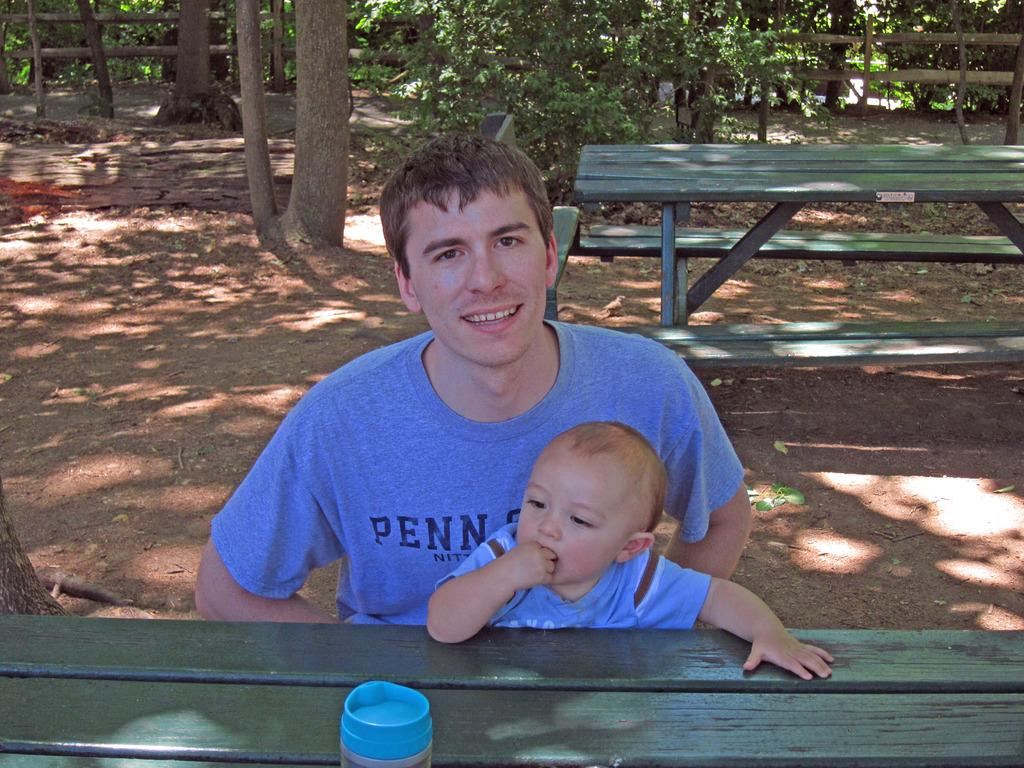Who is present in the image? There is a man and a baby in the image. What are they doing in the image? Both the man and the baby are sitting on a bench. Is there another bench in the image? Yes, there is another bench behind the man. What can be seen in the background of the image? Trees are visible in the background of the image. What type of office can be seen in the background of the image? There is no office present in the background of the image; it features trees instead. 